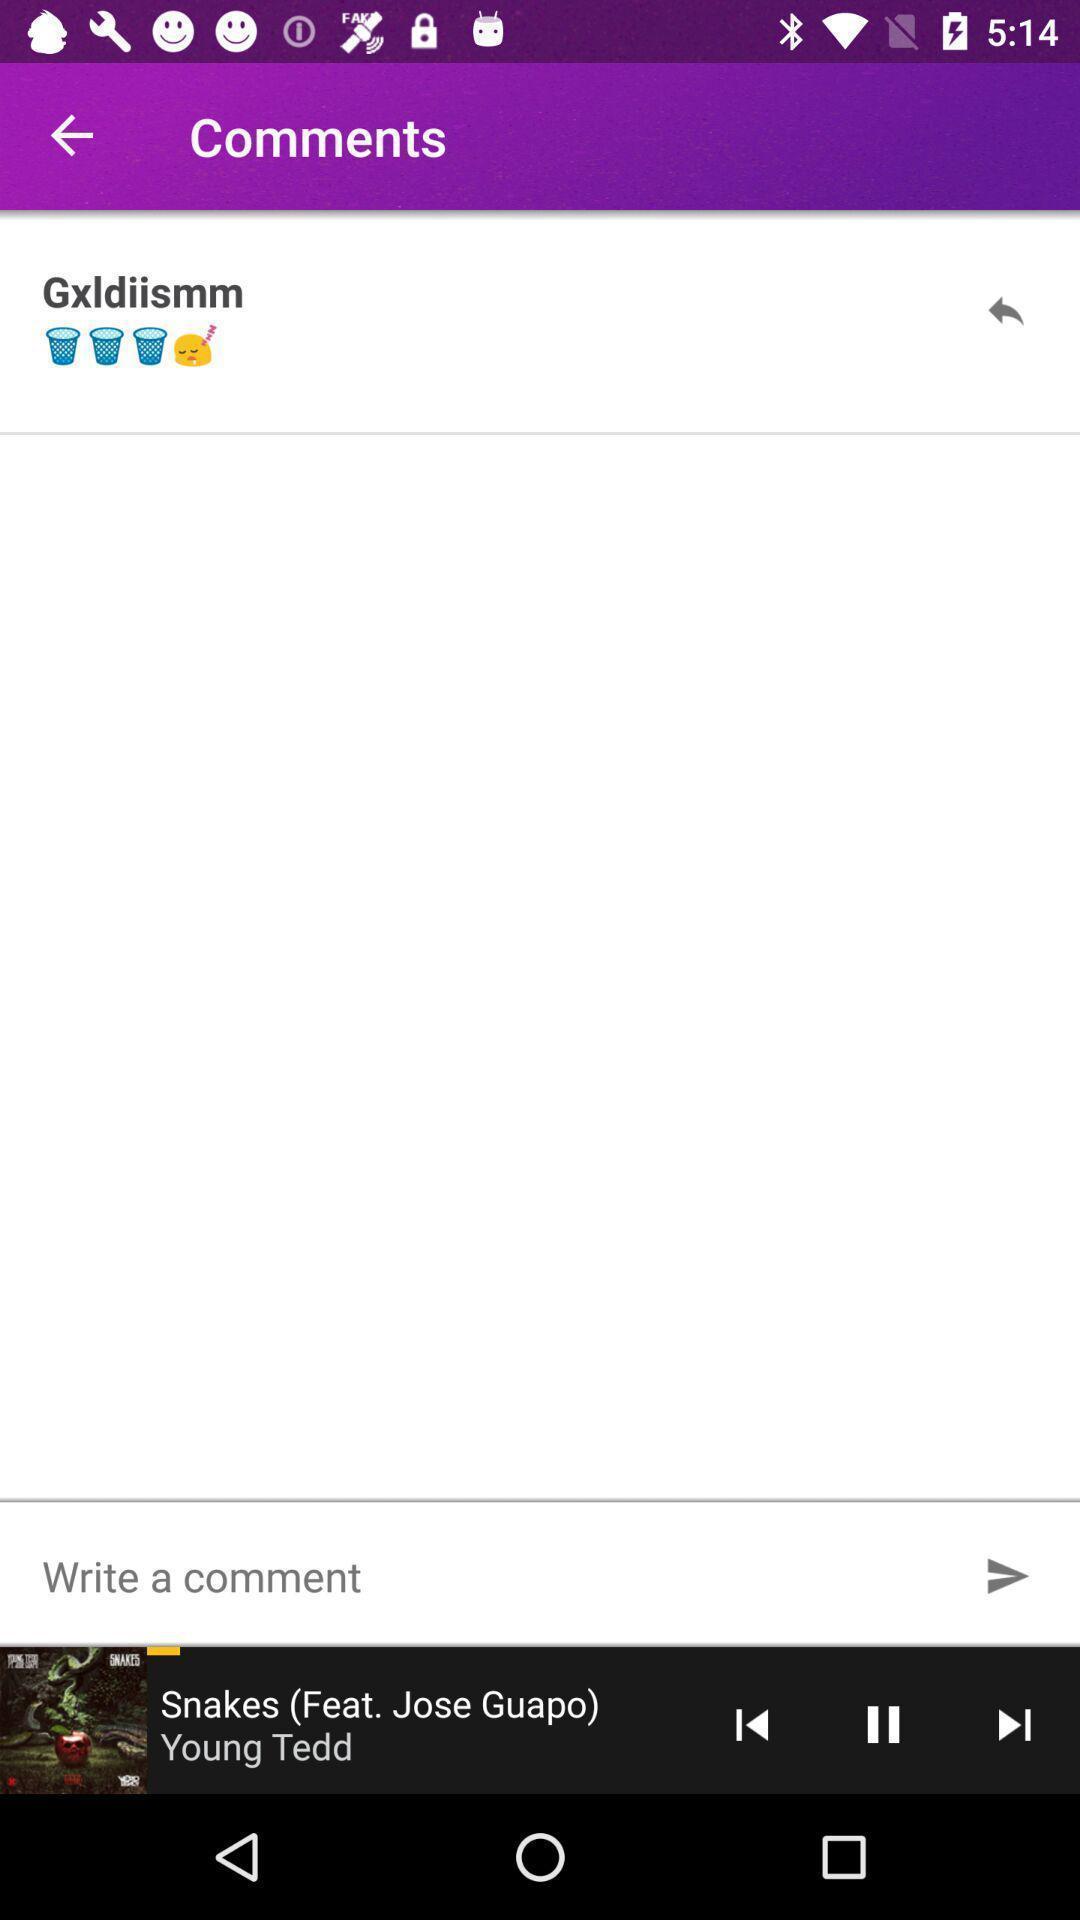Summarize the main components in this picture. Screen shows comments in a music app. 